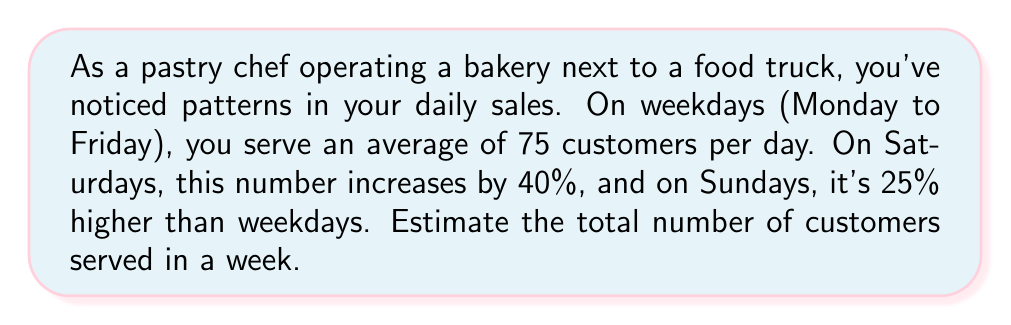Teach me how to tackle this problem. Let's break this down step-by-step:

1. Calculate weekday customers:
   - Weekdays: Monday to Friday (5 days)
   - Average customers per weekday: 75
   - Total weekday customers: $5 \times 75 = 375$

2. Calculate Saturday customers:
   - Saturday increase: 40% more than weekdays
   - Saturday customers: $75 \times (1 + 0.40) = 75 \times 1.40 = 105$

3. Calculate Sunday customers:
   - Sunday increase: 25% more than weekdays
   - Sunday customers: $75 \times (1 + 0.25) = 75 \times 1.25 = 93.75$

4. Sum up the total customers for the week:
   $$ \text{Total} = \text{Weekday} + \text{Saturday} + \text{Sunday} $$
   $$ \text{Total} = 375 + 105 + 93.75 = 573.75 $$

5. Since we're estimating, we'll round to the nearest whole number:
   $$ \text{Estimated total} \approx 574 \text{ customers} $$
Answer: The estimated total number of customers served in a week is 574. 